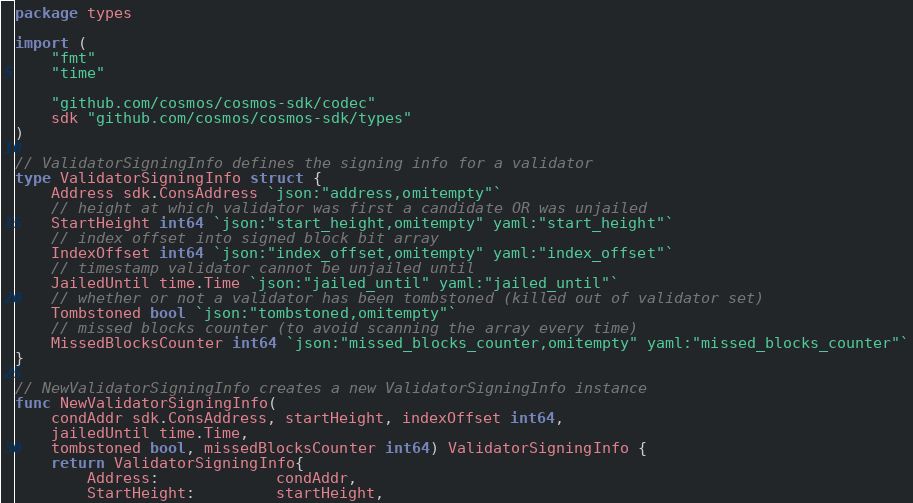<code> <loc_0><loc_0><loc_500><loc_500><_Go_>package types

import (
	"fmt"
	"time"

	"github.com/cosmos/cosmos-sdk/codec"
	sdk "github.com/cosmos/cosmos-sdk/types"
)

// ValidatorSigningInfo defines the signing info for a validator
type ValidatorSigningInfo struct {
	Address sdk.ConsAddress `json:"address,omitempty"`
	// height at which validator was first a candidate OR was unjailed
	StartHeight int64 `json:"start_height,omitempty" yaml:"start_height"`
	// index offset into signed block bit array
	IndexOffset int64 `json:"index_offset,omitempty" yaml:"index_offset"`
	// timestamp validator cannot be unjailed until
	JailedUntil time.Time `json:"jailed_until" yaml:"jailed_until"`
	// whether or not a validator has been tombstoned (killed out of validator set)
	Tombstoned bool `json:"tombstoned,omitempty"`
	// missed blocks counter (to avoid scanning the array every time)
	MissedBlocksCounter int64 `json:"missed_blocks_counter,omitempty" yaml:"missed_blocks_counter"`
}

// NewValidatorSigningInfo creates a new ValidatorSigningInfo instance
func NewValidatorSigningInfo(
	condAddr sdk.ConsAddress, startHeight, indexOffset int64,
	jailedUntil time.Time,
	tombstoned bool, missedBlocksCounter int64) ValidatorSigningInfo {
	return ValidatorSigningInfo{
		Address:             condAddr,
		StartHeight:         startHeight,</code> 